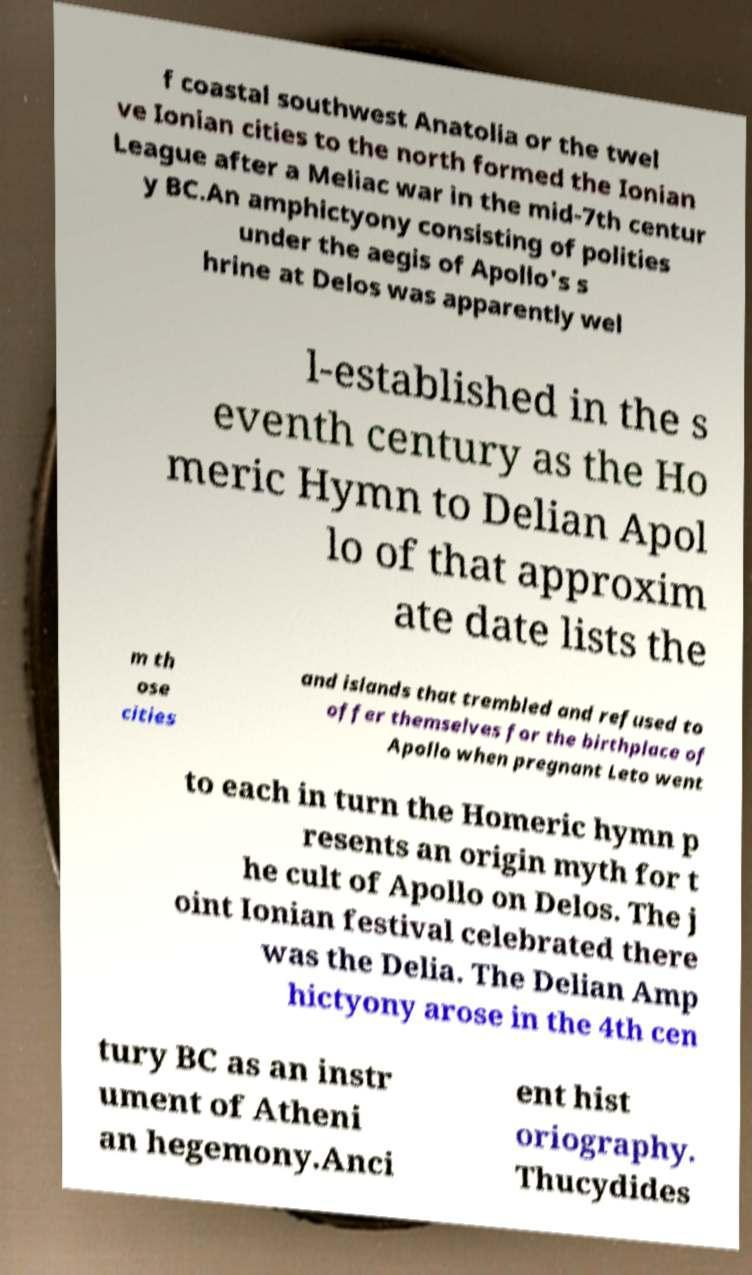Can you read and provide the text displayed in the image?This photo seems to have some interesting text. Can you extract and type it out for me? f coastal southwest Anatolia or the twel ve Ionian cities to the north formed the Ionian League after a Meliac war in the mid-7th centur y BC.An amphictyony consisting of polities under the aegis of Apollo's s hrine at Delos was apparently wel l-established in the s eventh century as the Ho meric Hymn to Delian Apol lo of that approxim ate date lists the m th ose cities and islands that trembled and refused to offer themselves for the birthplace of Apollo when pregnant Leto went to each in turn the Homeric hymn p resents an origin myth for t he cult of Apollo on Delos. The j oint Ionian festival celebrated there was the Delia. The Delian Amp hictyony arose in the 4th cen tury BC as an instr ument of Atheni an hegemony.Anci ent hist oriography. Thucydides 